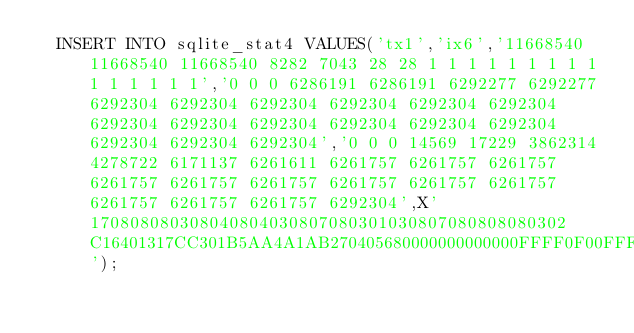<code> <loc_0><loc_0><loc_500><loc_500><_SQL_>  INSERT INTO sqlite_stat4 VALUES('tx1','ix6','11668540 11668540 11668540 8282 7043 28 28 1 1 1 1 1 1 1 1 1 1 1 1 1 1 1','0 0 0 6286191 6286191 6292277 6292277 6292304 6292304 6292304 6292304 6292304 6292304 6292304 6292304 6292304 6292304 6292304 6292304 6292304 6292304 6292304','0 0 0 14569 17229 3862314 4278722 6171137 6261611 6261757 6261757 6261757 6261757 6261757 6261757 6261757 6261757 6261757 6261757 6261757 6261757 6292304',X'170808080308040804030807080301030807080808080302C16401317CC301B5AA4A1AB270405680000000000000FFFF0F00FFFFC0F869E00000000048FD4C');</code> 